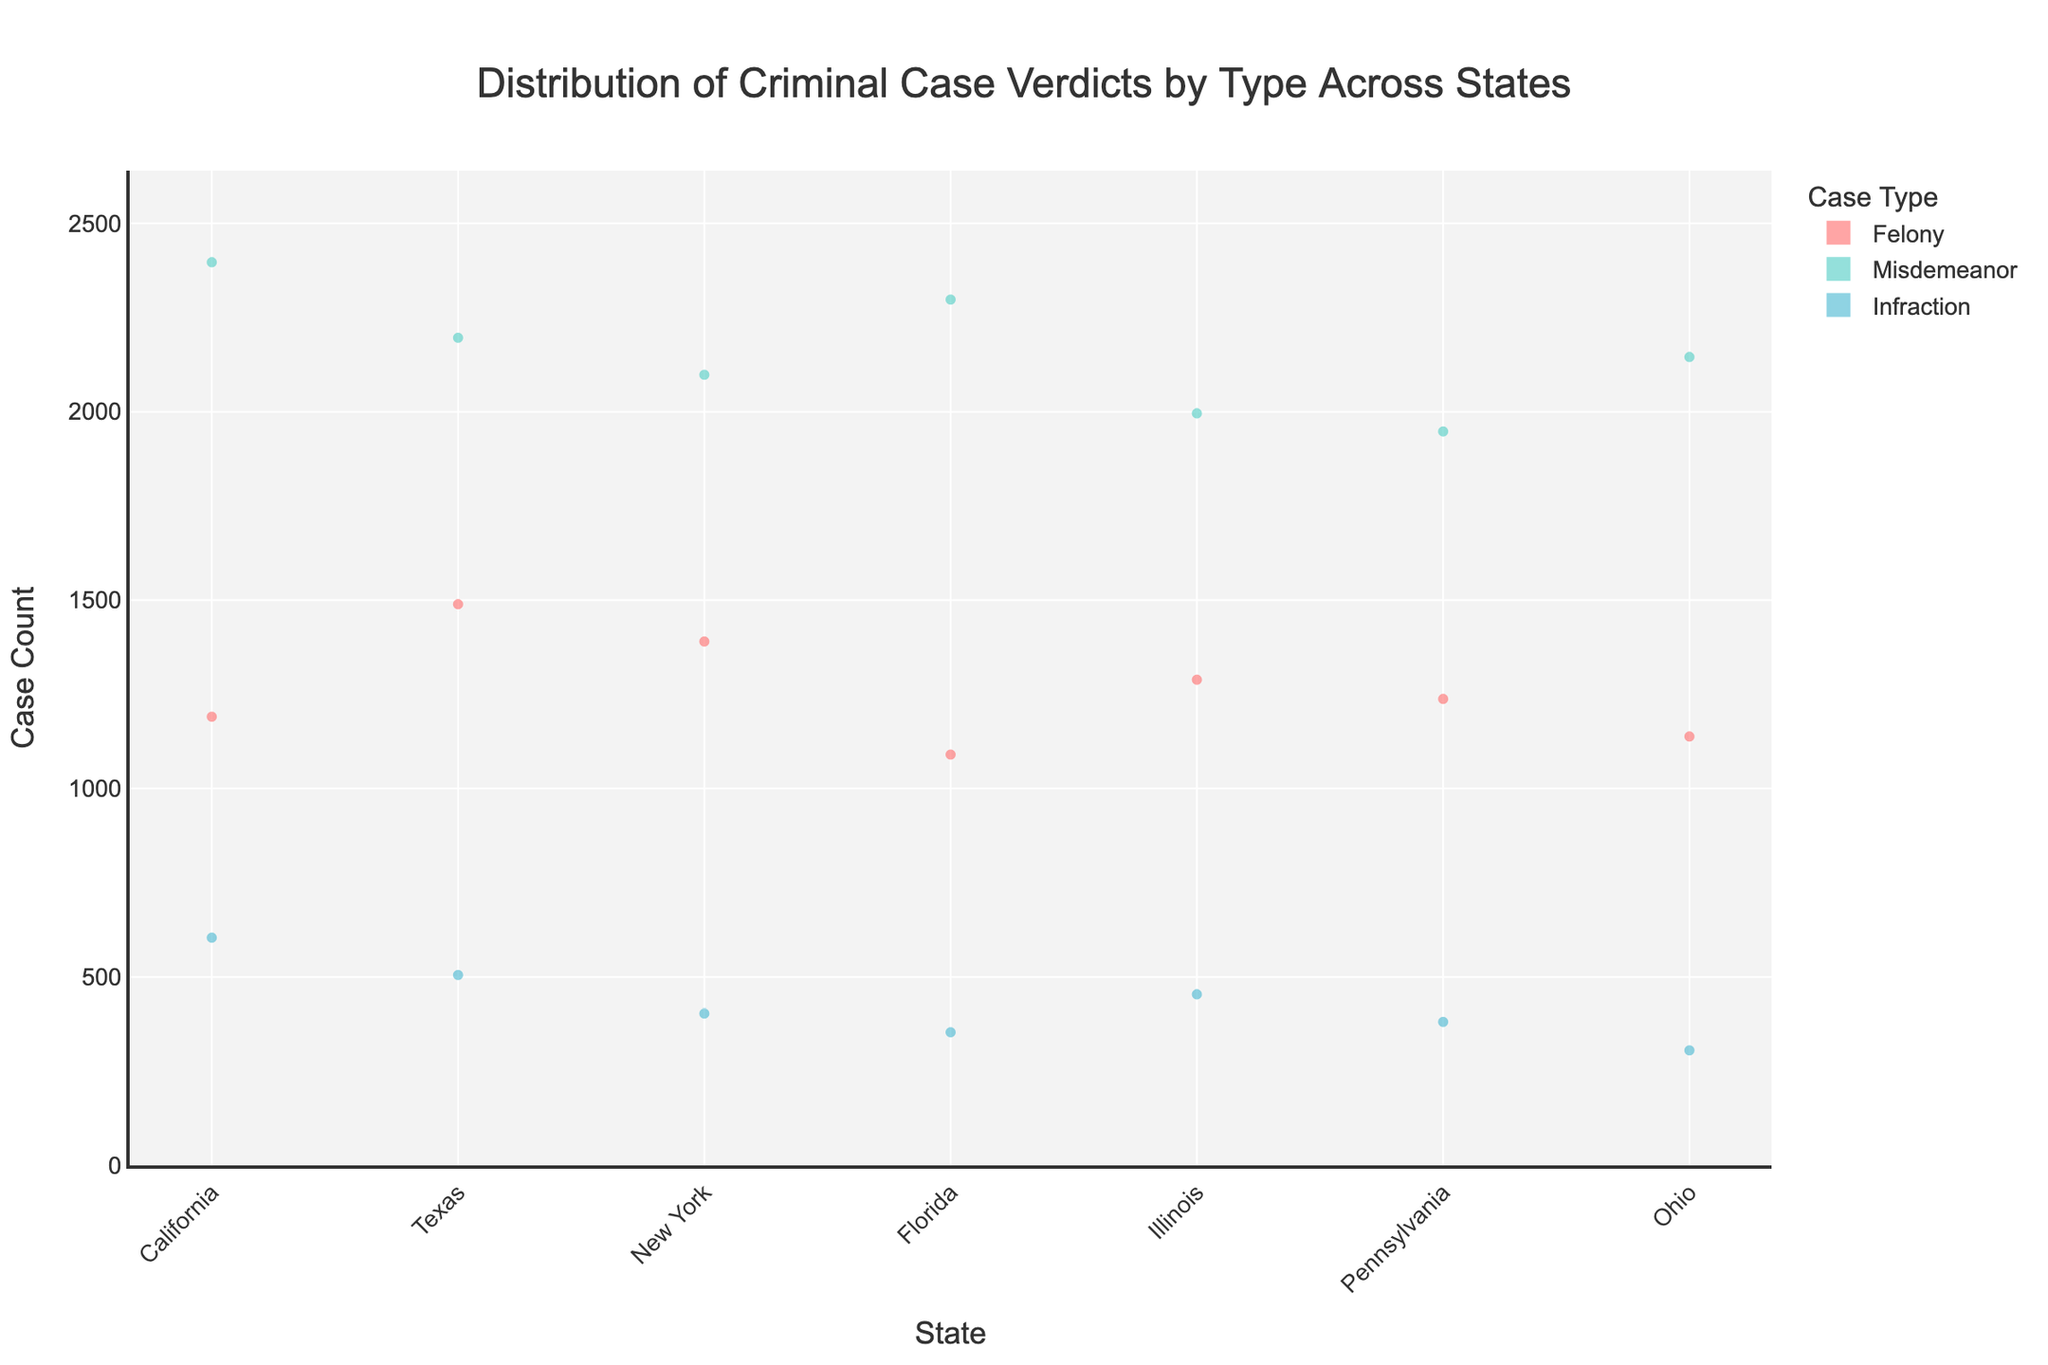What is the title of the chart? The title is at the top center of the chart and reads "Distribution of Criminal Case Verdicts by Type Across States"
Answer: Distribution of Criminal Case Verdicts by Type Across States How many states are represented in the chart? By counting the unique labels along the x-axis, there are six states: California, Texas, New York, Florida, Illinois, and Pennsylvania
Answer: 6 Which state has the highest count of misdemeanor cases? By comparing the heights of the viola plots labeled 'Misdemeanor' for each state, Texas has the highest number of misdemeanor cases
Answer: Texas What is the color used to represent felony cases? Looking at the color associated with 'Felony' in the legend, it is a shade of red (#FF6B6B)
Answer: Red How many case counts are there in New York for infractions? By observing the data point for New York under the 'Infraction' section it shows 400 case counts
Answer: 400 Which state has the smallest number of misdemeanor cases? By comparing the heights of the misdemeanor plots, Pennsylvania has the smallest number
Answer: Pennsylvania What is the mean case count across states for felony cases? Add all the felony case counts and divide by the number of states: (1200 + 1500 + 1400 + 1100 + 1300 + 1250) / 6 = 7750 / 6
Answer: 1291.67 Compare the number of felony cases in California to Ohio. Which state has more? From the chart, California has 1200 felony cases while Ohio has 1150 felony cases. So, California has more
Answer: California What is the sum of infraction cases across all states? Sum the infraction cases for each state: 600 + 500 + 400 + 350 + 450 + 375 + 300
Answer: 2975 Is the distribution of misdemeanor cases or felony cases wider in Texas? By comparing the shapes of the violin plots, the distribution for misdemeanor cases in Texas is wider than that for felony cases
Answer: Misdemeanor 